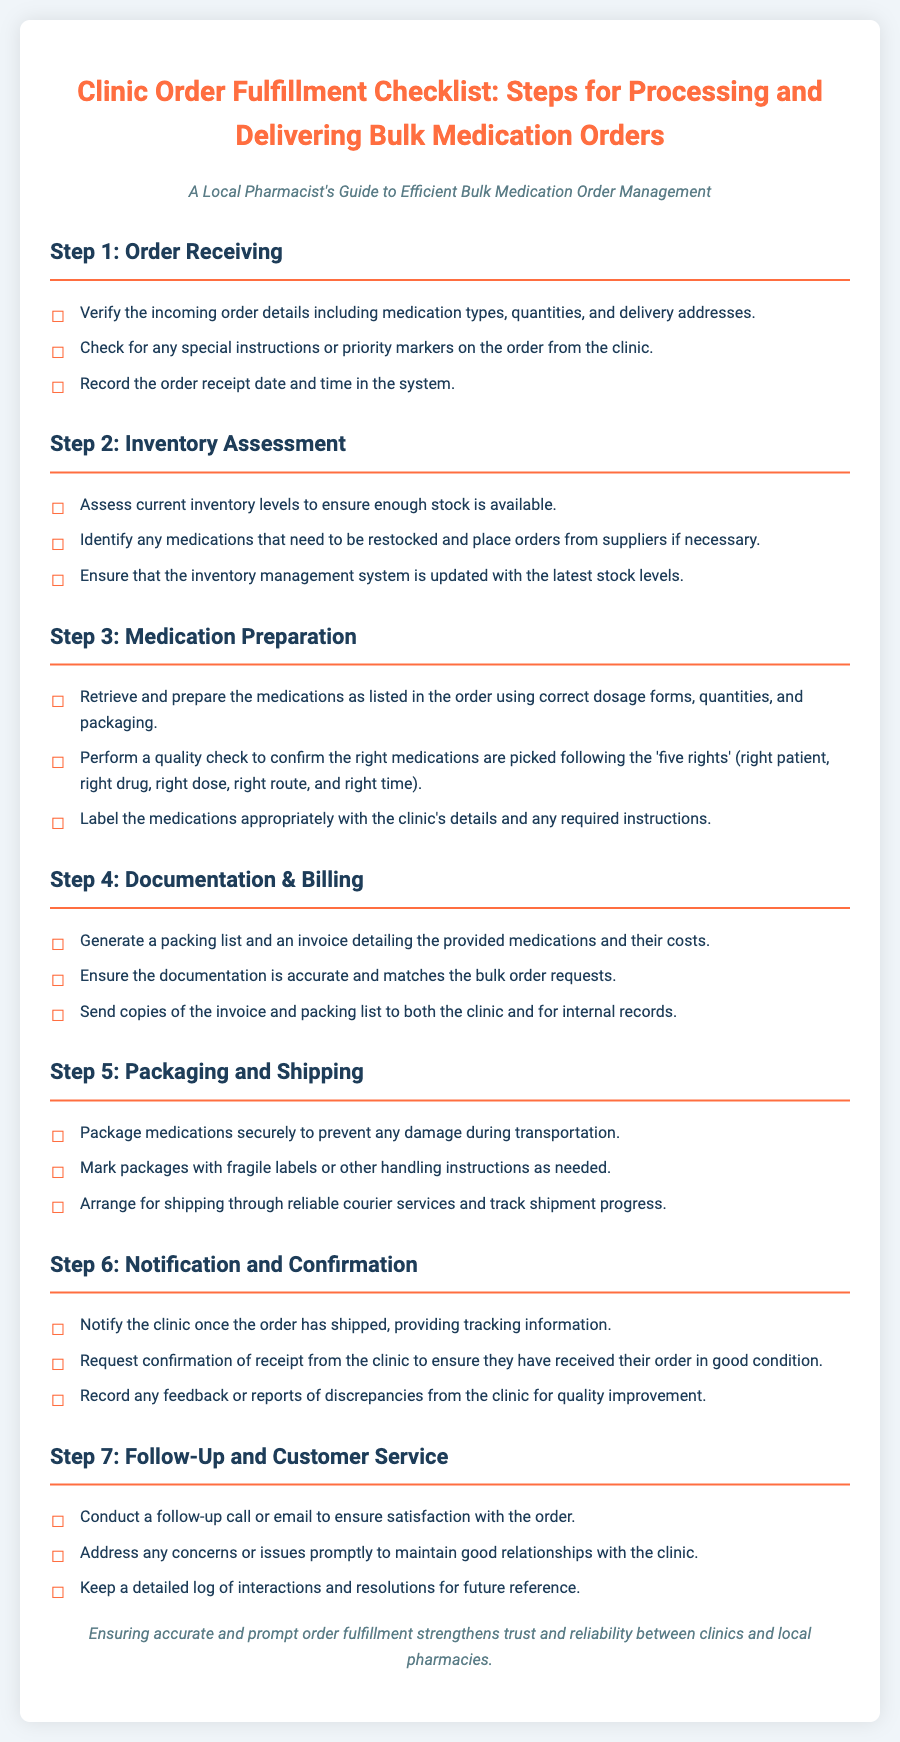What is the title of the checklist? The title provides the main subject of the document, which is crucial for understanding its purpose.
Answer: Clinic Order Fulfillment Checklist: Steps for Processing and Delivering Bulk Medication Orders What is the first step in the checklist? The first step indicates the initial action required for processing orders, structuring the checklist logically.
Answer: Order Receiving What should you check for in the incoming order details? This question focuses on the specific information required during the order receiving step.
Answer: Medication types, quantities, and delivery addresses How many steps are outlined in the checklist? This question helps to understand the overall structure and complexity of the process detailed in the checklist.
Answer: Seven What is performed during the quality check? This asks about a specific action taken to ensure correctness within the medication preparation step.
Answer: Confirm the right medications are picked following the 'five rights' What should be included in the packing list? This question focuses on the necessary documentation generated during the documentation and billing step.
Answer: Details of provided medications and their costs What is the purpose of notifying the clinic after shipping? This question seeks to clarify the importance of communication in the process after dispatching the order.
Answer: To provide tracking information What action should be taken during follow-up? This question aims to determine the steps for customer service and relationship maintenance after order fulfillment.
Answer: Conduct a follow-up call or email to ensure satisfaction with the order 